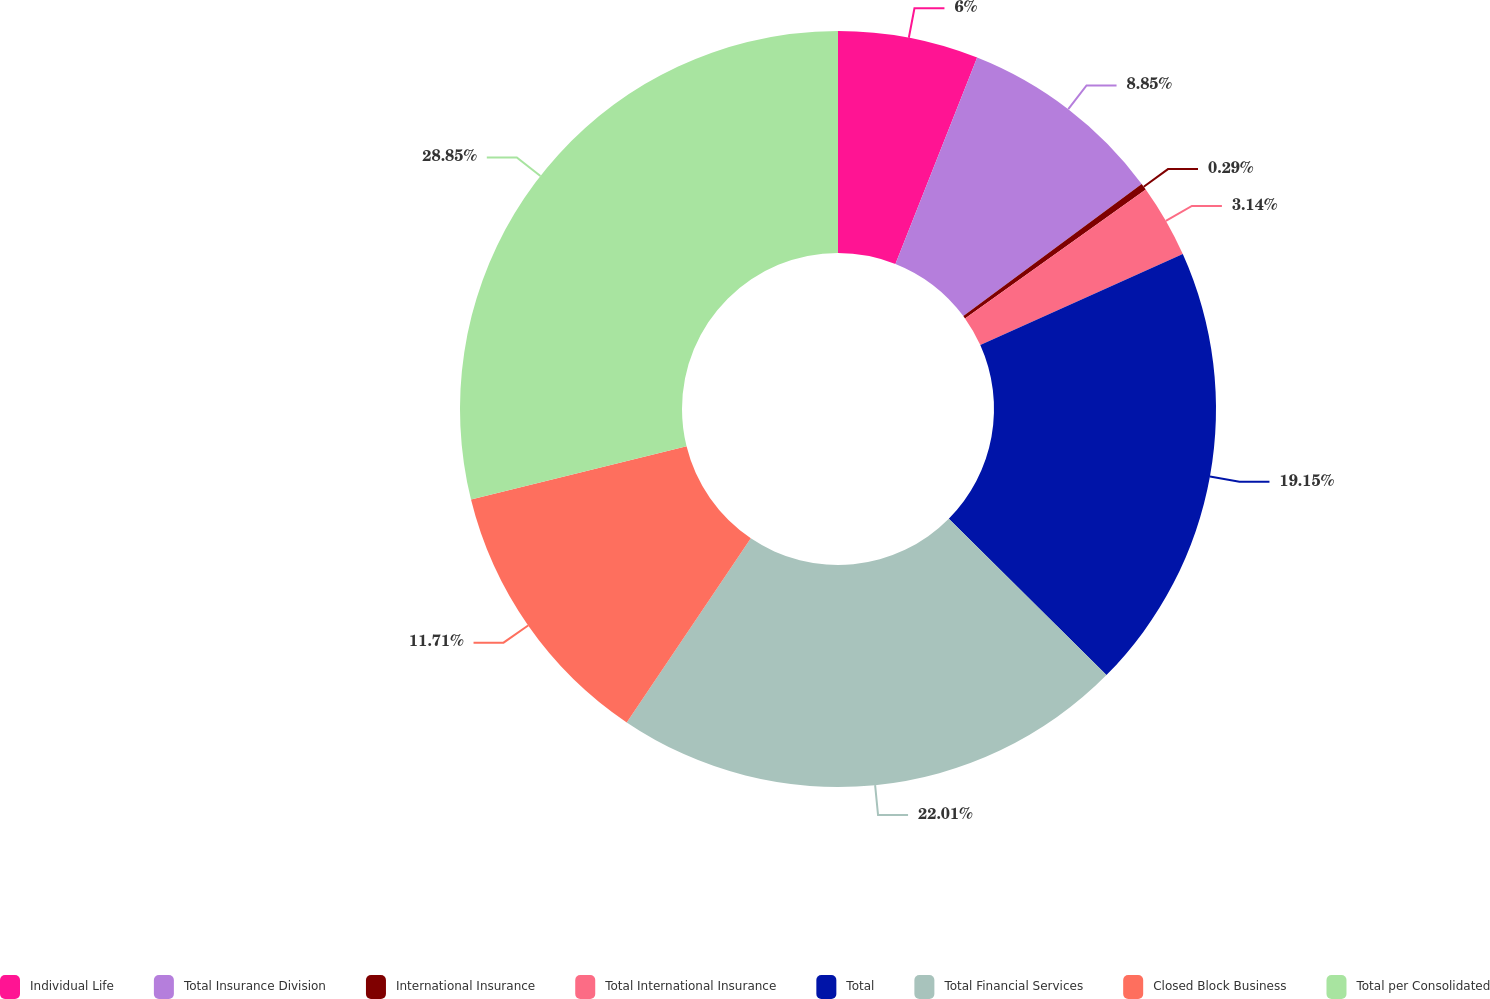Convert chart to OTSL. <chart><loc_0><loc_0><loc_500><loc_500><pie_chart><fcel>Individual Life<fcel>Total Insurance Division<fcel>International Insurance<fcel>Total International Insurance<fcel>Total<fcel>Total Financial Services<fcel>Closed Block Business<fcel>Total per Consolidated<nl><fcel>6.0%<fcel>8.85%<fcel>0.29%<fcel>3.14%<fcel>19.15%<fcel>22.01%<fcel>11.71%<fcel>28.85%<nl></chart> 